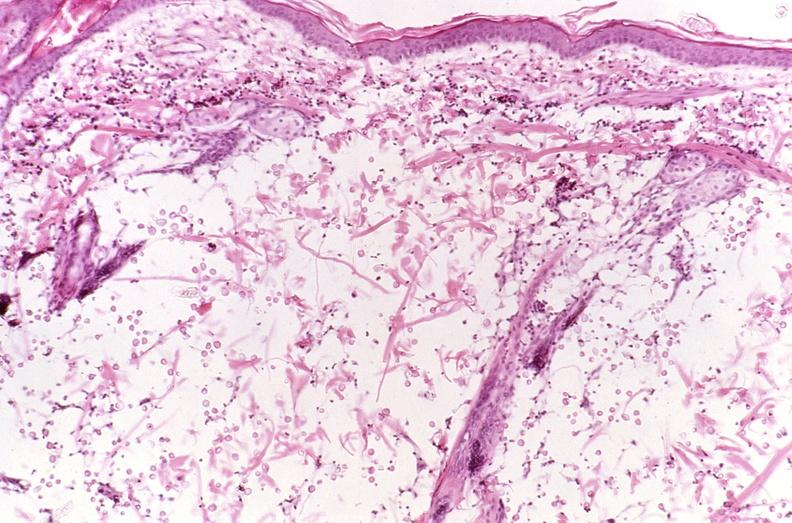does neuronophagia show cryptococcal dematitis?
Answer the question using a single word or phrase. No 